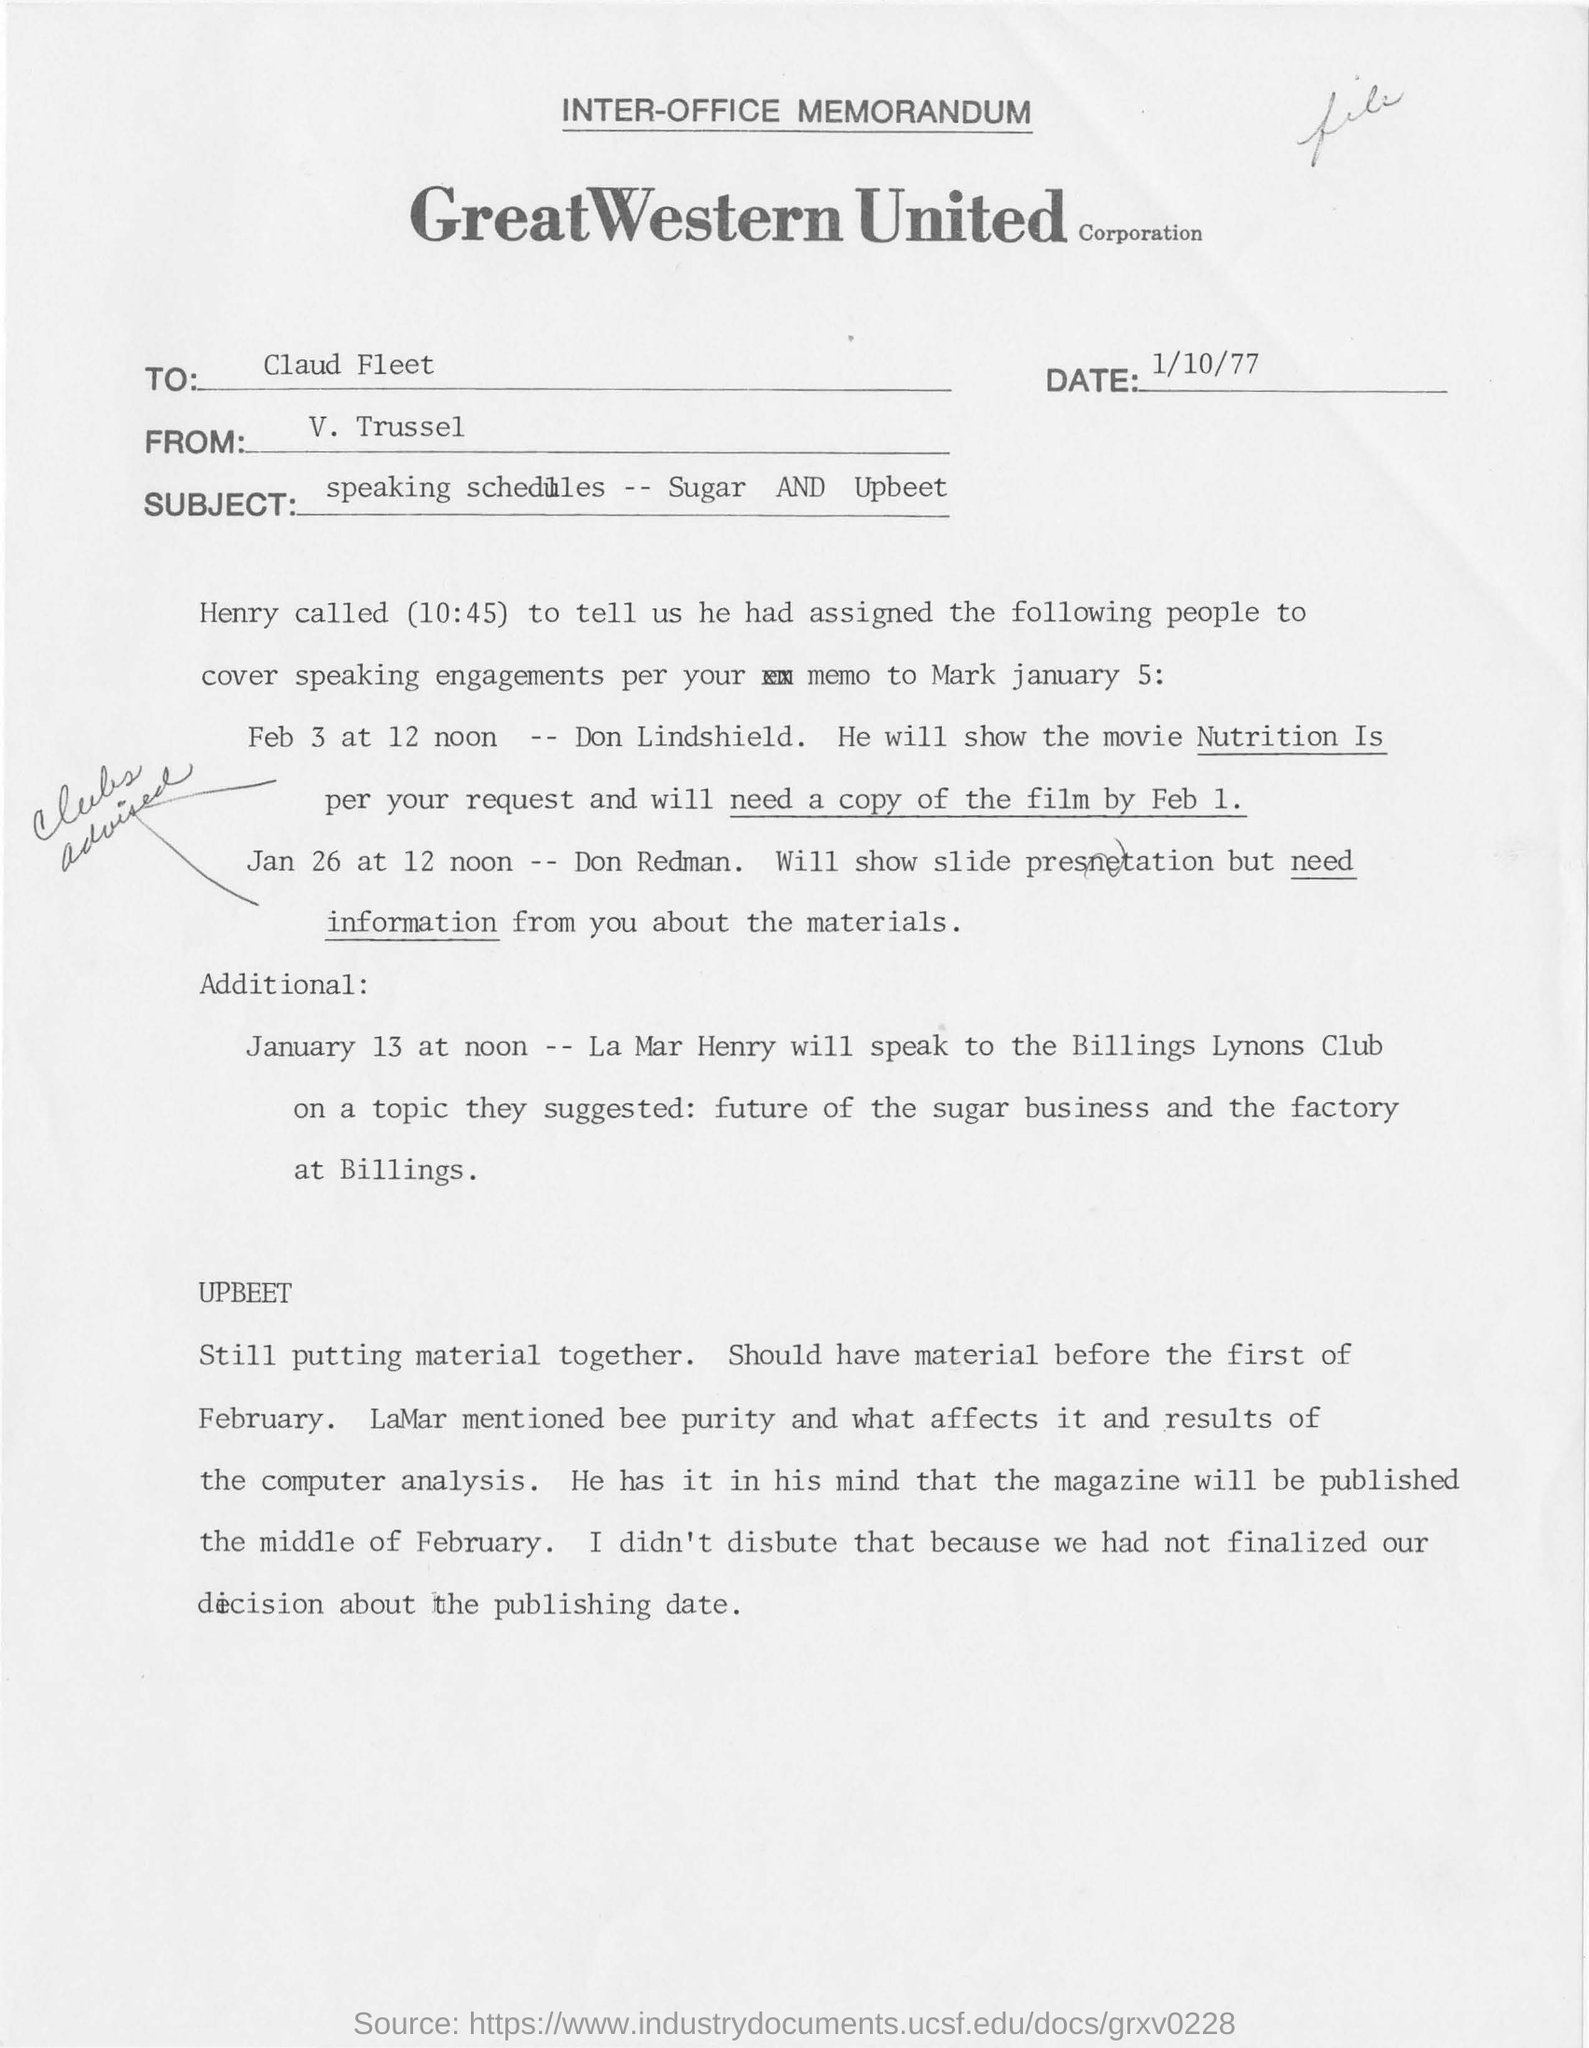What is the name of corporation?
Provide a succinct answer. Great Western United Corporation. Who is writing memorandum to claud fleet?
Make the answer very short. V. Trussel. Who are assigned for the slide presentation task on jan 26 at 12 noon?
Give a very brief answer. Don redman. Who assigned the people to speak as per memo ?
Your answer should be very brief. Henry. What is the subject of inter-office memorandum?
Your answer should be very brief. Speaking Schedules -- Sugar AND Upbeet. 